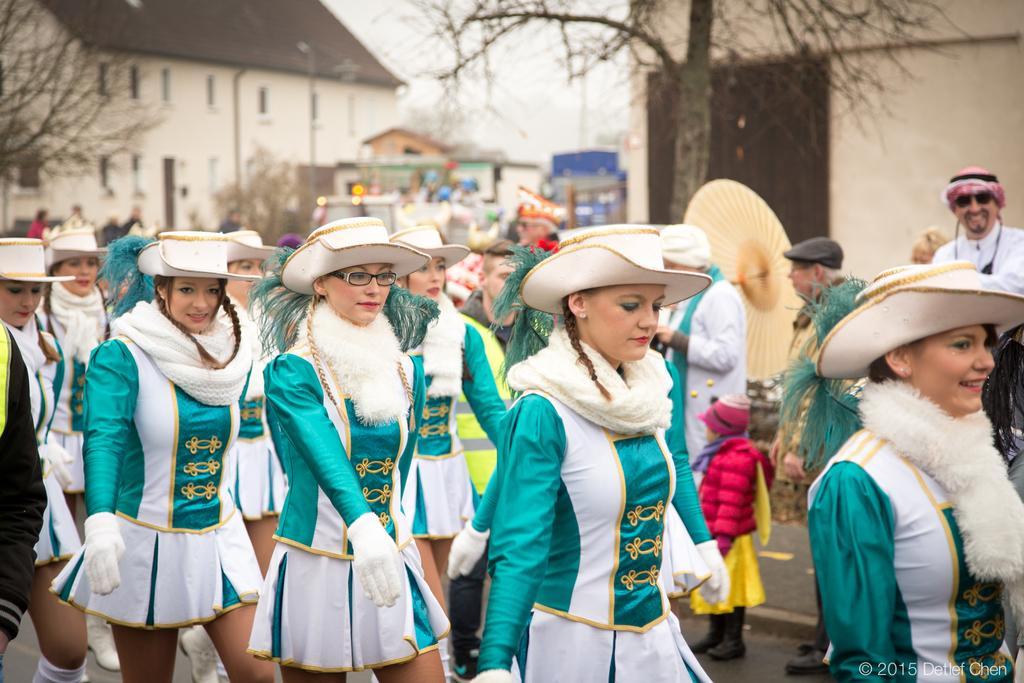In one or two sentences, can you explain what this image depicts? In this picture there is a woman who is wearing spectacle, hat, green dress and gloves. Here we can see group of women who are wearing same dress and walking on the road. On the right there is a man who is wearing white dress and goggles. He is smiling. In the background we can see vehicles, trees and buildings. Here we can see sky and clouds. 